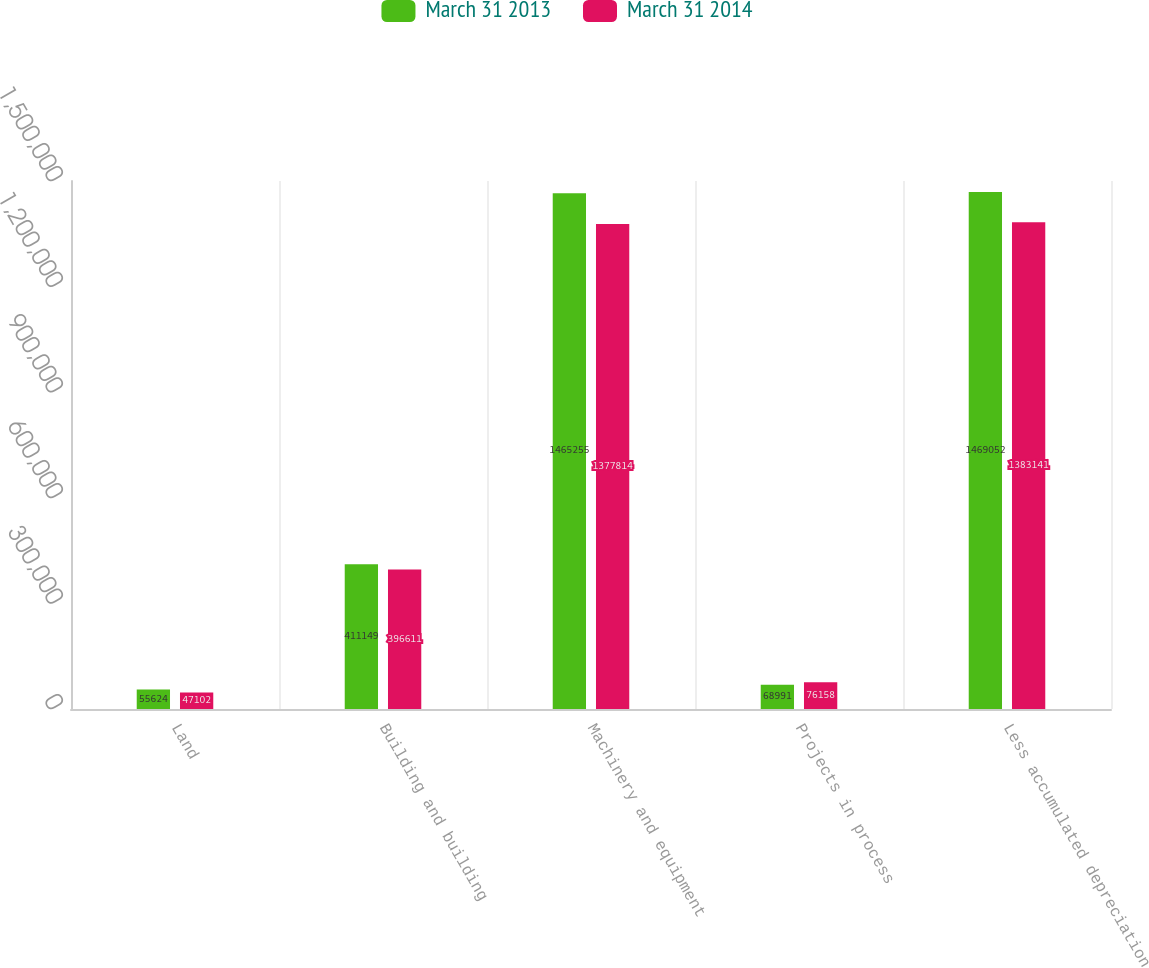<chart> <loc_0><loc_0><loc_500><loc_500><stacked_bar_chart><ecel><fcel>Land<fcel>Building and building<fcel>Machinery and equipment<fcel>Projects in process<fcel>Less accumulated depreciation<nl><fcel>March 31 2013<fcel>55624<fcel>411149<fcel>1.46526e+06<fcel>68991<fcel>1.46905e+06<nl><fcel>March 31 2014<fcel>47102<fcel>396611<fcel>1.37781e+06<fcel>76158<fcel>1.38314e+06<nl></chart> 